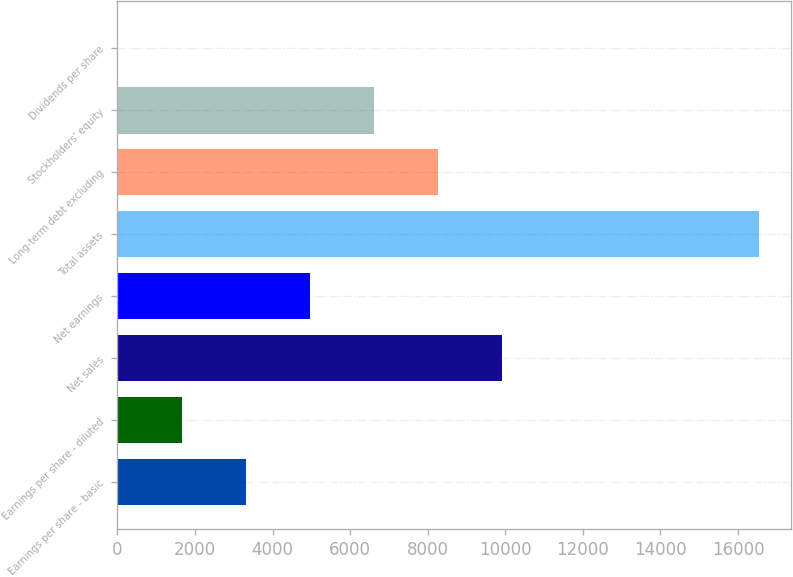Convert chart. <chart><loc_0><loc_0><loc_500><loc_500><bar_chart><fcel>Earnings per share - basic<fcel>Earnings per share - diluted<fcel>Net sales<fcel>Net earnings<fcel>Total assets<fcel>Long-term debt excluding<fcel>Stockholders' equity<fcel>Dividends per share<nl><fcel>3308.88<fcel>1654.99<fcel>9924.44<fcel>4962.77<fcel>16540<fcel>8270.55<fcel>6616.66<fcel>1.1<nl></chart> 